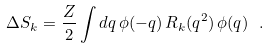Convert formula to latex. <formula><loc_0><loc_0><loc_500><loc_500>\Delta S _ { k } = \frac { Z } { 2 } \int d q \, \phi ( - q ) \, R _ { k } ( q ^ { 2 } ) \, \phi ( q ) \ .</formula> 